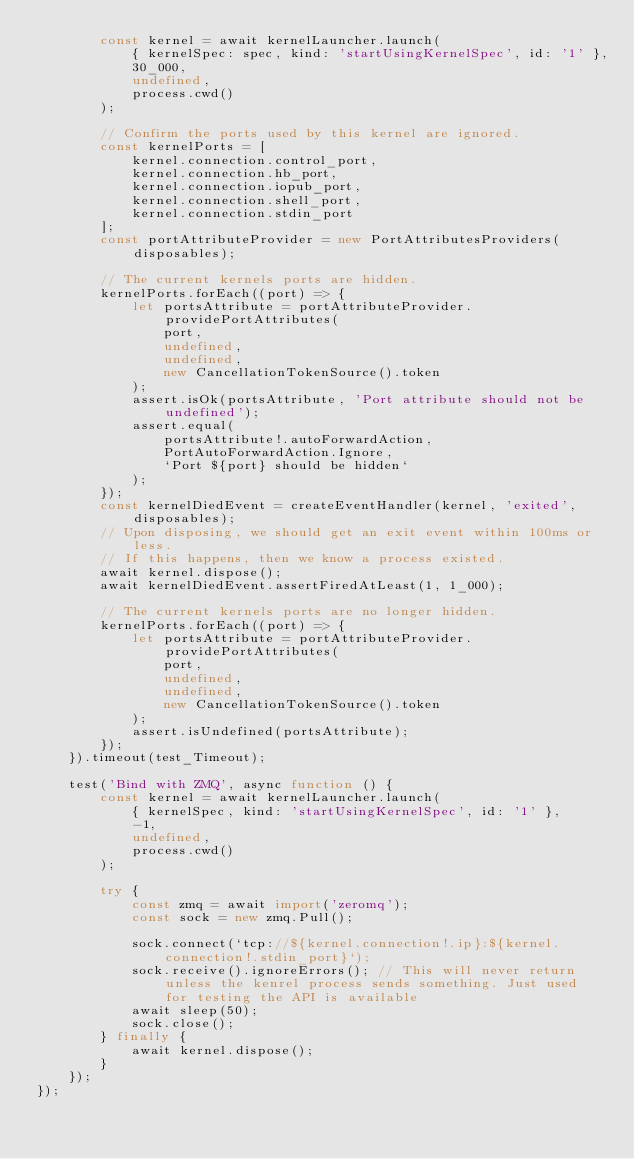Convert code to text. <code><loc_0><loc_0><loc_500><loc_500><_TypeScript_>        const kernel = await kernelLauncher.launch(
            { kernelSpec: spec, kind: 'startUsingKernelSpec', id: '1' },
            30_000,
            undefined,
            process.cwd()
        );

        // Confirm the ports used by this kernel are ignored.
        const kernelPorts = [
            kernel.connection.control_port,
            kernel.connection.hb_port,
            kernel.connection.iopub_port,
            kernel.connection.shell_port,
            kernel.connection.stdin_port
        ];
        const portAttributeProvider = new PortAttributesProviders(disposables);

        // The current kernels ports are hidden.
        kernelPorts.forEach((port) => {
            let portsAttribute = portAttributeProvider.providePortAttributes(
                port,
                undefined,
                undefined,
                new CancellationTokenSource().token
            );
            assert.isOk(portsAttribute, 'Port attribute should not be undefined');
            assert.equal(
                portsAttribute!.autoForwardAction,
                PortAutoForwardAction.Ignore,
                `Port ${port} should be hidden`
            );
        });
        const kernelDiedEvent = createEventHandler(kernel, 'exited', disposables);
        // Upon disposing, we should get an exit event within 100ms or less.
        // If this happens, then we know a process existed.
        await kernel.dispose();
        await kernelDiedEvent.assertFiredAtLeast(1, 1_000);

        // The current kernels ports are no longer hidden.
        kernelPorts.forEach((port) => {
            let portsAttribute = portAttributeProvider.providePortAttributes(
                port,
                undefined,
                undefined,
                new CancellationTokenSource().token
            );
            assert.isUndefined(portsAttribute);
        });
    }).timeout(test_Timeout);

    test('Bind with ZMQ', async function () {
        const kernel = await kernelLauncher.launch(
            { kernelSpec, kind: 'startUsingKernelSpec', id: '1' },
            -1,
            undefined,
            process.cwd()
        );

        try {
            const zmq = await import('zeromq');
            const sock = new zmq.Pull();

            sock.connect(`tcp://${kernel.connection!.ip}:${kernel.connection!.stdin_port}`);
            sock.receive().ignoreErrors(); // This will never return unless the kenrel process sends something. Just used for testing the API is available
            await sleep(50);
            sock.close();
        } finally {
            await kernel.dispose();
        }
    });
});
</code> 